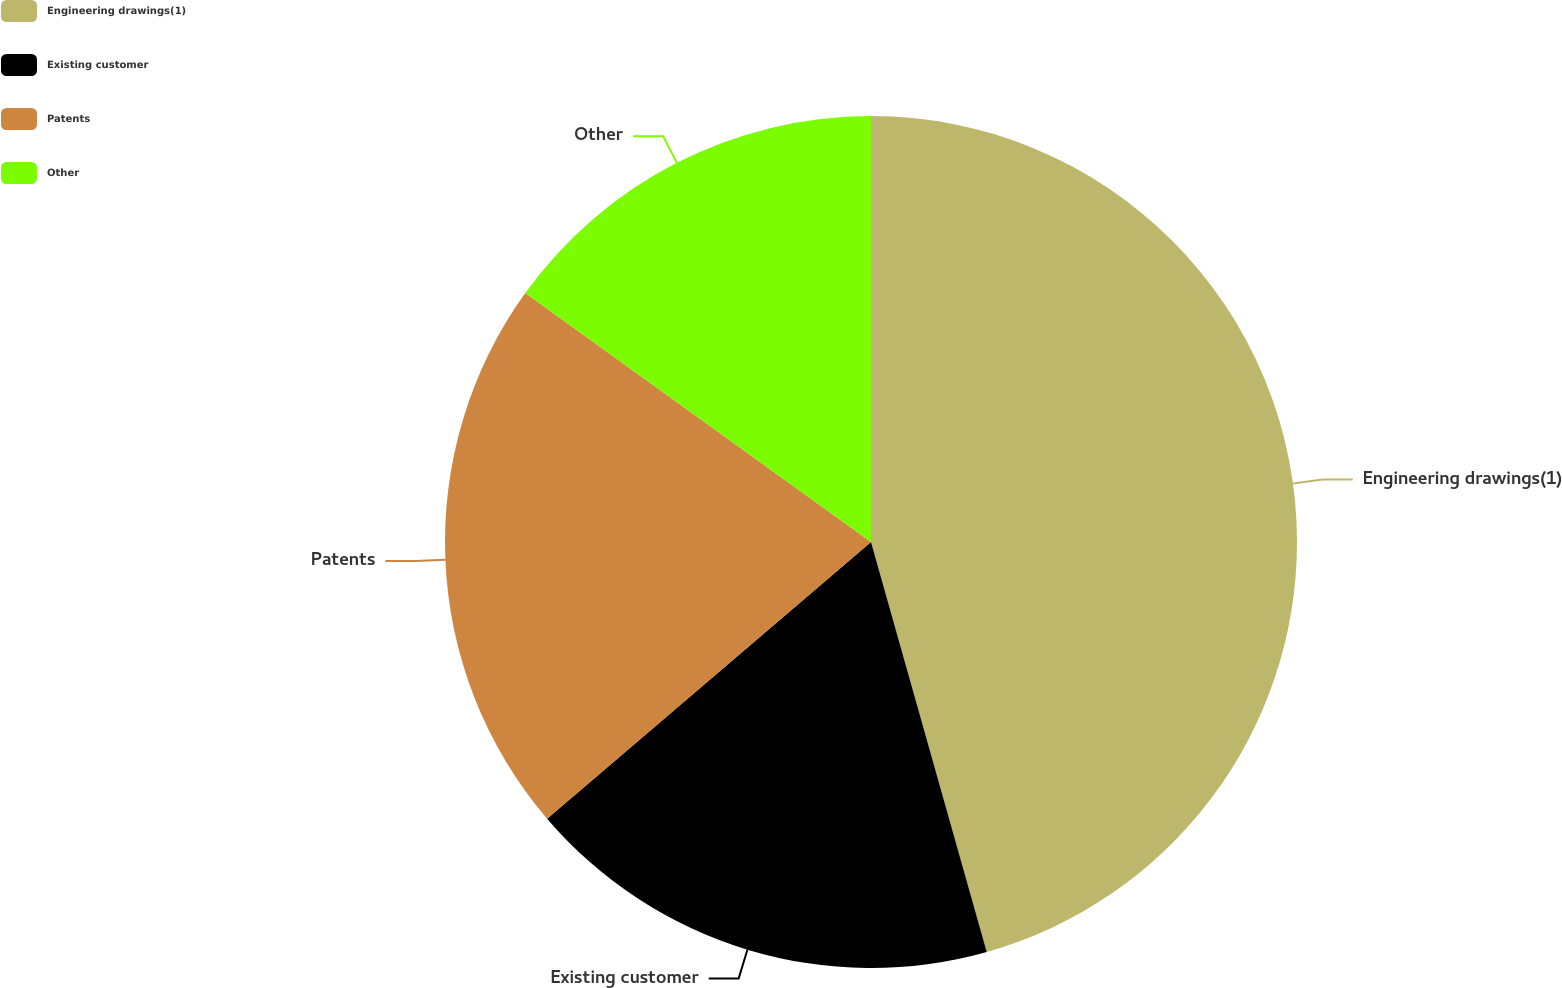Convert chart to OTSL. <chart><loc_0><loc_0><loc_500><loc_500><pie_chart><fcel>Engineering drawings(1)<fcel>Existing customer<fcel>Patents<fcel>Other<nl><fcel>45.62%<fcel>18.13%<fcel>21.18%<fcel>15.07%<nl></chart> 